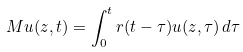<formula> <loc_0><loc_0><loc_500><loc_500>M u ( z , t ) = \int _ { 0 } ^ { t } r ( t - \tau ) u ( z , \tau ) \, d \tau</formula> 